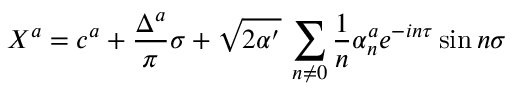Convert formula to latex. <formula><loc_0><loc_0><loc_500><loc_500>X ^ { a } = c ^ { a } + \frac { \Delta ^ { a } } { \pi } \sigma + \sqrt { 2 \alpha ^ { \prime } } \, \sum _ { n \neq 0 } \frac { 1 } { n } \alpha _ { n } ^ { a } e ^ { - i n \tau } \sin n \sigma</formula> 